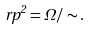<formula> <loc_0><loc_0><loc_500><loc_500>\ r p ^ { 2 } = \Omega / \sim .</formula> 